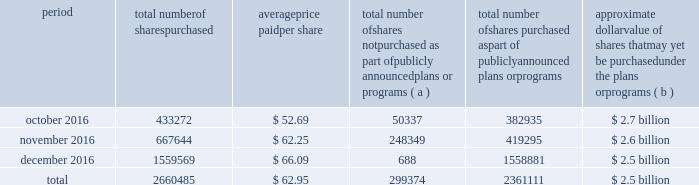Table of contents the table discloses purchases of shares of our common stock made by us or on our behalf during the fourth quarter of 2016 .
Period total number of shares purchased average price paid per share total number of shares not purchased as part of publicly announced plans or programs ( a ) total number of shares purchased as part of publicly announced plans or programs approximate dollar value of shares that may yet be purchased under the plans or programs ( b ) .
( a ) the shares reported in this column represent purchases settled in the fourth quarter of 2016 relating to ( i ) our purchases of shares in open-market transactions to meet our obligations under stock-based compensation plans , and ( ii ) our purchases of shares from our employees and non-employee directors in connection with the exercise of stock options , the vesting of restricted stock , and other stock compensation transactions in accordance with the terms of our stock-based compensation plans .
( b ) on july 13 , 2015 , we announced that our board of directors authorized our purchase of up to $ 2.5 billion of our outstanding common stock .
This authorization has no expiration date .
As of december 31 , 2016 , the approximate dollar value of shares that may yet be purchased under the 2015 authorization is $ 40 million .
On september 21 , 2016 , we announced that our board of directors authorized our purchase of up to an additional $ 2.5 billion of our outstanding common stock with no expiration date .
As of december 31 , 2016 , no purchases have been made under the 2016 authorization. .
As of december 31 , 2016 what was the percent of the shares outstanding of the 2015 program yet to be purchased? 
Computations: (40 / 2.5)
Answer: 16.0. Table of contents the table discloses purchases of shares of our common stock made by us or on our behalf during the fourth quarter of 2016 .
Period total number of shares purchased average price paid per share total number of shares not purchased as part of publicly announced plans or programs ( a ) total number of shares purchased as part of publicly announced plans or programs approximate dollar value of shares that may yet be purchased under the plans or programs ( b ) .
( a ) the shares reported in this column represent purchases settled in the fourth quarter of 2016 relating to ( i ) our purchases of shares in open-market transactions to meet our obligations under stock-based compensation plans , and ( ii ) our purchases of shares from our employees and non-employee directors in connection with the exercise of stock options , the vesting of restricted stock , and other stock compensation transactions in accordance with the terms of our stock-based compensation plans .
( b ) on july 13 , 2015 , we announced that our board of directors authorized our purchase of up to $ 2.5 billion of our outstanding common stock .
This authorization has no expiration date .
As of december 31 , 2016 , the approximate dollar value of shares that may yet be purchased under the 2015 authorization is $ 40 million .
On september 21 , 2016 , we announced that our board of directors authorized our purchase of up to an additional $ 2.5 billion of our outstanding common stock with no expiration date .
As of december 31 , 2016 , no purchases have been made under the 2016 authorization. .
What is the percentage increase of shares purchased as part of publicly announced plans from nov 2016 to dec 2016? 
Computations: ((1558881 - 419295) / 419295)
Answer: 2.71786. 